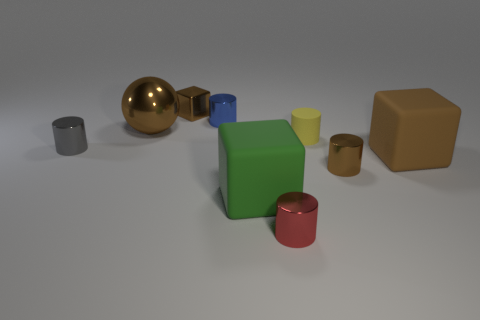Subtract all red cylinders. How many cylinders are left? 4 Subtract all large rubber blocks. How many blocks are left? 1 Subtract 1 spheres. How many spheres are left? 0 Subtract all blocks. How many objects are left? 6 Subtract all blue cylinders. Subtract all cyan blocks. How many cylinders are left? 4 Subtract all green spheres. How many yellow blocks are left? 0 Subtract all large red metallic spheres. Subtract all small brown metal cylinders. How many objects are left? 8 Add 2 spheres. How many spheres are left? 3 Add 5 tiny blue objects. How many tiny blue objects exist? 6 Subtract 0 cyan cylinders. How many objects are left? 9 